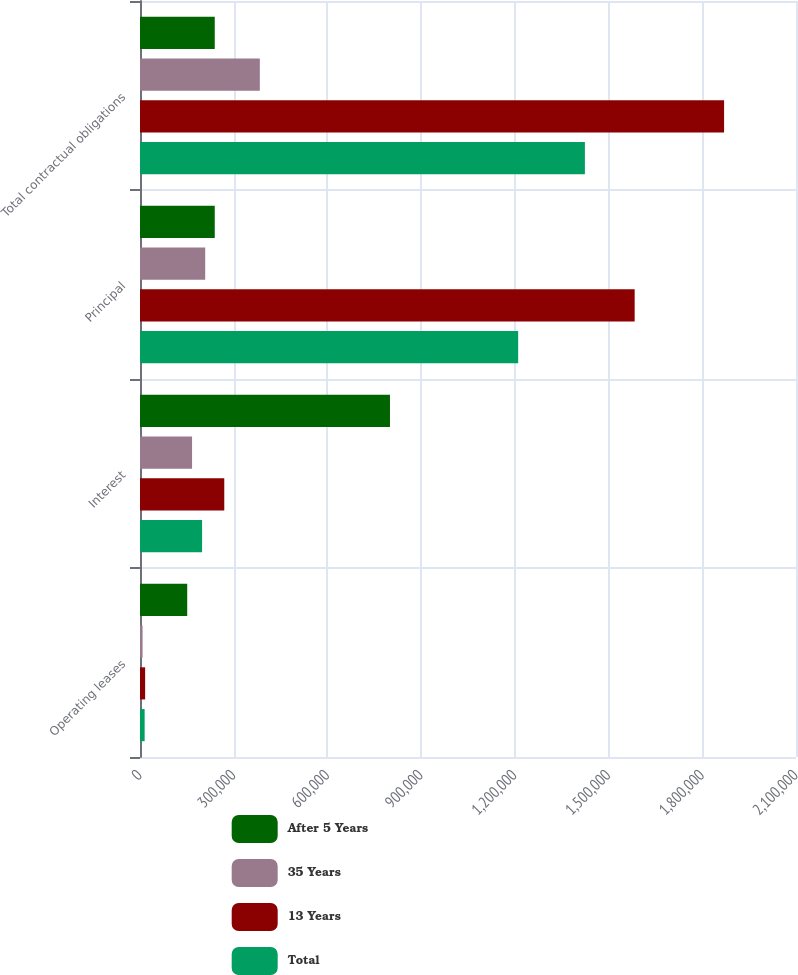Convert chart. <chart><loc_0><loc_0><loc_500><loc_500><stacked_bar_chart><ecel><fcel>Operating leases<fcel>Interest<fcel>Principal<fcel>Total contractual obligations<nl><fcel>After 5 Years<fcel>151158<fcel>800214<fcel>239268<fcel>239268<nl><fcel>35 Years<fcel>8203<fcel>166690<fcel>208742<fcel>383635<nl><fcel>13 Years<fcel>16444<fcel>269795<fcel>1.58354e+06<fcel>1.86978e+06<nl><fcel>Total<fcel>14858<fcel>198755<fcel>1.21059e+06<fcel>1.42421e+06<nl></chart> 